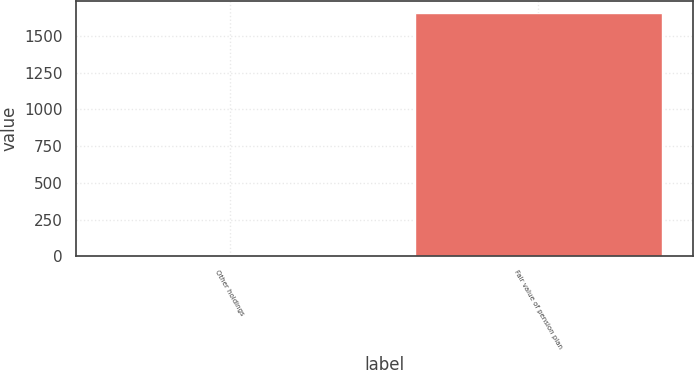Convert chart. <chart><loc_0><loc_0><loc_500><loc_500><bar_chart><fcel>Other holdings<fcel>Fair value of pension plan<nl><fcel>8<fcel>1655<nl></chart> 